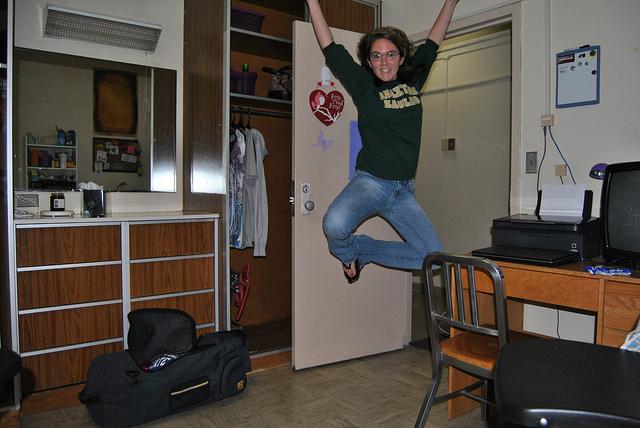Is the girl sad?
Answer briefly. No. Is she walking?
Give a very brief answer. No. Is she wearing a suntop?
Be succinct. No. What material is the desk?
Keep it brief. Wood. 